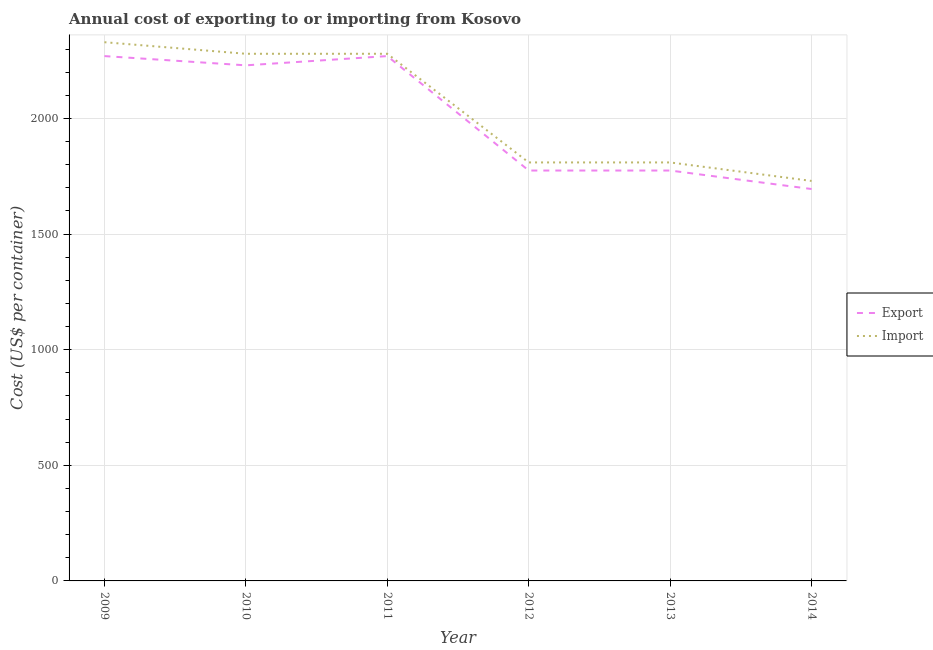How many different coloured lines are there?
Your answer should be very brief. 2. Does the line corresponding to import cost intersect with the line corresponding to export cost?
Ensure brevity in your answer.  No. Is the number of lines equal to the number of legend labels?
Keep it short and to the point. Yes. What is the export cost in 2009?
Provide a short and direct response. 2270. Across all years, what is the maximum export cost?
Ensure brevity in your answer.  2270. Across all years, what is the minimum export cost?
Your answer should be very brief. 1695. In which year was the export cost minimum?
Make the answer very short. 2014. What is the total export cost in the graph?
Give a very brief answer. 1.20e+04. What is the difference between the import cost in 2010 and that in 2012?
Your answer should be very brief. 470. What is the difference between the import cost in 2010 and the export cost in 2009?
Provide a short and direct response. 10. What is the average import cost per year?
Provide a succinct answer. 2040. In the year 2014, what is the difference between the export cost and import cost?
Provide a short and direct response. -35. What is the ratio of the import cost in 2009 to that in 2013?
Provide a succinct answer. 1.29. Is the export cost in 2013 less than that in 2014?
Give a very brief answer. No. Is the difference between the export cost in 2009 and 2013 greater than the difference between the import cost in 2009 and 2013?
Ensure brevity in your answer.  No. What is the difference between the highest and the lowest import cost?
Provide a succinct answer. 600. In how many years, is the import cost greater than the average import cost taken over all years?
Provide a succinct answer. 3. Is the sum of the export cost in 2009 and 2011 greater than the maximum import cost across all years?
Ensure brevity in your answer.  Yes. Does the import cost monotonically increase over the years?
Your answer should be compact. No. Is the import cost strictly greater than the export cost over the years?
Your answer should be very brief. Yes. How many lines are there?
Give a very brief answer. 2. How many years are there in the graph?
Provide a short and direct response. 6. Are the values on the major ticks of Y-axis written in scientific E-notation?
Keep it short and to the point. No. How many legend labels are there?
Ensure brevity in your answer.  2. What is the title of the graph?
Give a very brief answer. Annual cost of exporting to or importing from Kosovo. Does "Public funds" appear as one of the legend labels in the graph?
Your response must be concise. No. What is the label or title of the X-axis?
Your answer should be compact. Year. What is the label or title of the Y-axis?
Your answer should be compact. Cost (US$ per container). What is the Cost (US$ per container) in Export in 2009?
Provide a succinct answer. 2270. What is the Cost (US$ per container) of Import in 2009?
Give a very brief answer. 2330. What is the Cost (US$ per container) in Export in 2010?
Offer a terse response. 2230. What is the Cost (US$ per container) of Import in 2010?
Give a very brief answer. 2280. What is the Cost (US$ per container) in Export in 2011?
Offer a very short reply. 2270. What is the Cost (US$ per container) of Import in 2011?
Ensure brevity in your answer.  2280. What is the Cost (US$ per container) of Export in 2012?
Make the answer very short. 1775. What is the Cost (US$ per container) in Import in 2012?
Make the answer very short. 1810. What is the Cost (US$ per container) of Export in 2013?
Ensure brevity in your answer.  1775. What is the Cost (US$ per container) in Import in 2013?
Make the answer very short. 1810. What is the Cost (US$ per container) of Export in 2014?
Give a very brief answer. 1695. What is the Cost (US$ per container) in Import in 2014?
Offer a very short reply. 1730. Across all years, what is the maximum Cost (US$ per container) in Export?
Offer a very short reply. 2270. Across all years, what is the maximum Cost (US$ per container) in Import?
Ensure brevity in your answer.  2330. Across all years, what is the minimum Cost (US$ per container) in Export?
Offer a terse response. 1695. Across all years, what is the minimum Cost (US$ per container) of Import?
Keep it short and to the point. 1730. What is the total Cost (US$ per container) of Export in the graph?
Give a very brief answer. 1.20e+04. What is the total Cost (US$ per container) in Import in the graph?
Your answer should be compact. 1.22e+04. What is the difference between the Cost (US$ per container) of Import in 2009 and that in 2010?
Give a very brief answer. 50. What is the difference between the Cost (US$ per container) in Import in 2009 and that in 2011?
Ensure brevity in your answer.  50. What is the difference between the Cost (US$ per container) of Export in 2009 and that in 2012?
Provide a short and direct response. 495. What is the difference between the Cost (US$ per container) in Import in 2009 and that in 2012?
Make the answer very short. 520. What is the difference between the Cost (US$ per container) of Export in 2009 and that in 2013?
Your response must be concise. 495. What is the difference between the Cost (US$ per container) in Import in 2009 and that in 2013?
Keep it short and to the point. 520. What is the difference between the Cost (US$ per container) of Export in 2009 and that in 2014?
Make the answer very short. 575. What is the difference between the Cost (US$ per container) of Import in 2009 and that in 2014?
Your answer should be compact. 600. What is the difference between the Cost (US$ per container) of Export in 2010 and that in 2011?
Your answer should be compact. -40. What is the difference between the Cost (US$ per container) of Import in 2010 and that in 2011?
Provide a short and direct response. 0. What is the difference between the Cost (US$ per container) of Export in 2010 and that in 2012?
Provide a succinct answer. 455. What is the difference between the Cost (US$ per container) of Import in 2010 and that in 2012?
Provide a succinct answer. 470. What is the difference between the Cost (US$ per container) of Export in 2010 and that in 2013?
Offer a terse response. 455. What is the difference between the Cost (US$ per container) in Import in 2010 and that in 2013?
Make the answer very short. 470. What is the difference between the Cost (US$ per container) in Export in 2010 and that in 2014?
Provide a succinct answer. 535. What is the difference between the Cost (US$ per container) of Import in 2010 and that in 2014?
Keep it short and to the point. 550. What is the difference between the Cost (US$ per container) of Export in 2011 and that in 2012?
Keep it short and to the point. 495. What is the difference between the Cost (US$ per container) of Import in 2011 and that in 2012?
Keep it short and to the point. 470. What is the difference between the Cost (US$ per container) in Export in 2011 and that in 2013?
Ensure brevity in your answer.  495. What is the difference between the Cost (US$ per container) of Import in 2011 and that in 2013?
Keep it short and to the point. 470. What is the difference between the Cost (US$ per container) of Export in 2011 and that in 2014?
Your answer should be compact. 575. What is the difference between the Cost (US$ per container) of Import in 2011 and that in 2014?
Ensure brevity in your answer.  550. What is the difference between the Cost (US$ per container) of Export in 2012 and that in 2013?
Your response must be concise. 0. What is the difference between the Cost (US$ per container) in Import in 2012 and that in 2013?
Give a very brief answer. 0. What is the difference between the Cost (US$ per container) in Export in 2012 and that in 2014?
Provide a short and direct response. 80. What is the difference between the Cost (US$ per container) of Import in 2013 and that in 2014?
Provide a short and direct response. 80. What is the difference between the Cost (US$ per container) in Export in 2009 and the Cost (US$ per container) in Import in 2011?
Ensure brevity in your answer.  -10. What is the difference between the Cost (US$ per container) of Export in 2009 and the Cost (US$ per container) of Import in 2012?
Offer a very short reply. 460. What is the difference between the Cost (US$ per container) in Export in 2009 and the Cost (US$ per container) in Import in 2013?
Offer a very short reply. 460. What is the difference between the Cost (US$ per container) in Export in 2009 and the Cost (US$ per container) in Import in 2014?
Keep it short and to the point. 540. What is the difference between the Cost (US$ per container) in Export in 2010 and the Cost (US$ per container) in Import in 2012?
Your answer should be very brief. 420. What is the difference between the Cost (US$ per container) in Export in 2010 and the Cost (US$ per container) in Import in 2013?
Your response must be concise. 420. What is the difference between the Cost (US$ per container) in Export in 2010 and the Cost (US$ per container) in Import in 2014?
Offer a very short reply. 500. What is the difference between the Cost (US$ per container) of Export in 2011 and the Cost (US$ per container) of Import in 2012?
Give a very brief answer. 460. What is the difference between the Cost (US$ per container) of Export in 2011 and the Cost (US$ per container) of Import in 2013?
Provide a succinct answer. 460. What is the difference between the Cost (US$ per container) of Export in 2011 and the Cost (US$ per container) of Import in 2014?
Your answer should be compact. 540. What is the difference between the Cost (US$ per container) of Export in 2012 and the Cost (US$ per container) of Import in 2013?
Your answer should be very brief. -35. What is the difference between the Cost (US$ per container) of Export in 2012 and the Cost (US$ per container) of Import in 2014?
Provide a short and direct response. 45. What is the difference between the Cost (US$ per container) in Export in 2013 and the Cost (US$ per container) in Import in 2014?
Provide a short and direct response. 45. What is the average Cost (US$ per container) of Export per year?
Provide a succinct answer. 2002.5. What is the average Cost (US$ per container) of Import per year?
Provide a short and direct response. 2040. In the year 2009, what is the difference between the Cost (US$ per container) of Export and Cost (US$ per container) of Import?
Your answer should be very brief. -60. In the year 2010, what is the difference between the Cost (US$ per container) in Export and Cost (US$ per container) in Import?
Give a very brief answer. -50. In the year 2011, what is the difference between the Cost (US$ per container) of Export and Cost (US$ per container) of Import?
Offer a very short reply. -10. In the year 2012, what is the difference between the Cost (US$ per container) in Export and Cost (US$ per container) in Import?
Keep it short and to the point. -35. In the year 2013, what is the difference between the Cost (US$ per container) of Export and Cost (US$ per container) of Import?
Your response must be concise. -35. In the year 2014, what is the difference between the Cost (US$ per container) of Export and Cost (US$ per container) of Import?
Your answer should be very brief. -35. What is the ratio of the Cost (US$ per container) of Export in 2009 to that in 2010?
Your answer should be compact. 1.02. What is the ratio of the Cost (US$ per container) of Import in 2009 to that in 2010?
Give a very brief answer. 1.02. What is the ratio of the Cost (US$ per container) in Export in 2009 to that in 2011?
Provide a short and direct response. 1. What is the ratio of the Cost (US$ per container) in Import in 2009 to that in 2011?
Give a very brief answer. 1.02. What is the ratio of the Cost (US$ per container) of Export in 2009 to that in 2012?
Your response must be concise. 1.28. What is the ratio of the Cost (US$ per container) of Import in 2009 to that in 2012?
Your answer should be compact. 1.29. What is the ratio of the Cost (US$ per container) of Export in 2009 to that in 2013?
Keep it short and to the point. 1.28. What is the ratio of the Cost (US$ per container) of Import in 2009 to that in 2013?
Provide a succinct answer. 1.29. What is the ratio of the Cost (US$ per container) of Export in 2009 to that in 2014?
Offer a very short reply. 1.34. What is the ratio of the Cost (US$ per container) in Import in 2009 to that in 2014?
Provide a succinct answer. 1.35. What is the ratio of the Cost (US$ per container) in Export in 2010 to that in 2011?
Your answer should be compact. 0.98. What is the ratio of the Cost (US$ per container) of Import in 2010 to that in 2011?
Your answer should be very brief. 1. What is the ratio of the Cost (US$ per container) of Export in 2010 to that in 2012?
Provide a short and direct response. 1.26. What is the ratio of the Cost (US$ per container) in Import in 2010 to that in 2012?
Offer a very short reply. 1.26. What is the ratio of the Cost (US$ per container) in Export in 2010 to that in 2013?
Your answer should be compact. 1.26. What is the ratio of the Cost (US$ per container) in Import in 2010 to that in 2013?
Your answer should be compact. 1.26. What is the ratio of the Cost (US$ per container) of Export in 2010 to that in 2014?
Your response must be concise. 1.32. What is the ratio of the Cost (US$ per container) of Import in 2010 to that in 2014?
Your answer should be compact. 1.32. What is the ratio of the Cost (US$ per container) of Export in 2011 to that in 2012?
Keep it short and to the point. 1.28. What is the ratio of the Cost (US$ per container) in Import in 2011 to that in 2012?
Your answer should be compact. 1.26. What is the ratio of the Cost (US$ per container) of Export in 2011 to that in 2013?
Keep it short and to the point. 1.28. What is the ratio of the Cost (US$ per container) of Import in 2011 to that in 2013?
Make the answer very short. 1.26. What is the ratio of the Cost (US$ per container) of Export in 2011 to that in 2014?
Provide a short and direct response. 1.34. What is the ratio of the Cost (US$ per container) of Import in 2011 to that in 2014?
Your response must be concise. 1.32. What is the ratio of the Cost (US$ per container) in Export in 2012 to that in 2014?
Provide a succinct answer. 1.05. What is the ratio of the Cost (US$ per container) in Import in 2012 to that in 2014?
Your answer should be very brief. 1.05. What is the ratio of the Cost (US$ per container) of Export in 2013 to that in 2014?
Offer a terse response. 1.05. What is the ratio of the Cost (US$ per container) in Import in 2013 to that in 2014?
Provide a short and direct response. 1.05. What is the difference between the highest and the second highest Cost (US$ per container) of Import?
Your response must be concise. 50. What is the difference between the highest and the lowest Cost (US$ per container) of Export?
Your response must be concise. 575. What is the difference between the highest and the lowest Cost (US$ per container) of Import?
Your answer should be compact. 600. 